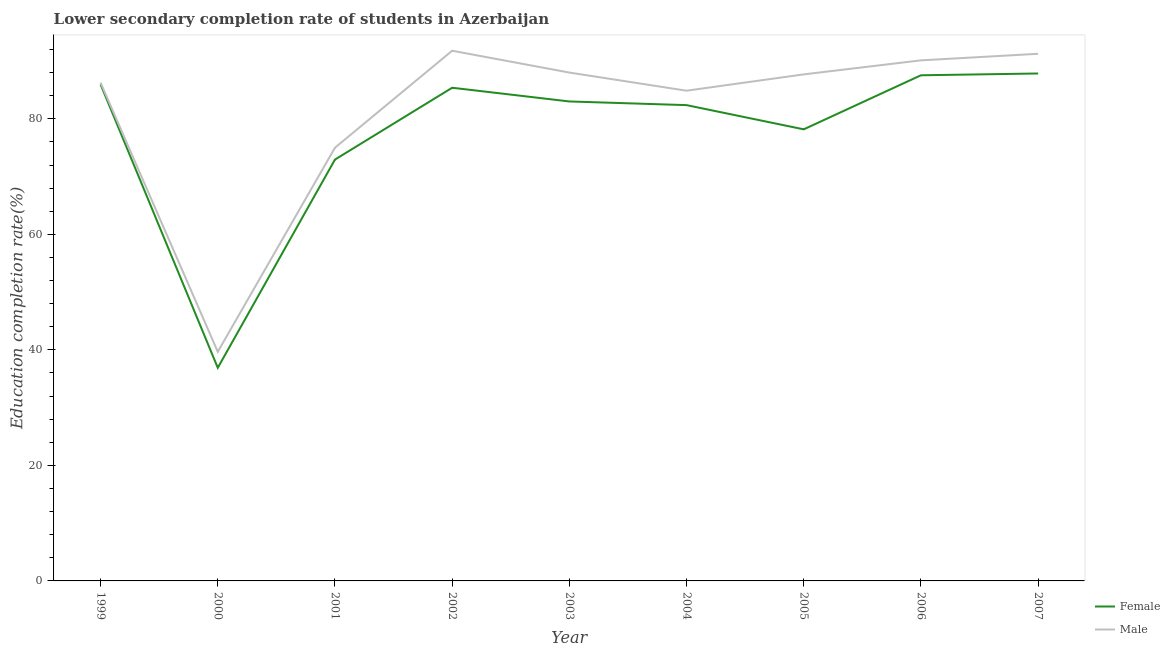Is the number of lines equal to the number of legend labels?
Give a very brief answer. Yes. What is the education completion rate of male students in 2001?
Your response must be concise. 75. Across all years, what is the maximum education completion rate of female students?
Your answer should be compact. 87.85. Across all years, what is the minimum education completion rate of male students?
Offer a very short reply. 39.67. In which year was the education completion rate of male students maximum?
Your answer should be very brief. 2002. In which year was the education completion rate of male students minimum?
Your response must be concise. 2000. What is the total education completion rate of female students in the graph?
Give a very brief answer. 700.11. What is the difference between the education completion rate of female students in 1999 and that in 2003?
Offer a terse response. 2.94. What is the difference between the education completion rate of male students in 2005 and the education completion rate of female students in 2003?
Provide a short and direct response. 4.69. What is the average education completion rate of female students per year?
Keep it short and to the point. 77.79. In the year 2002, what is the difference between the education completion rate of female students and education completion rate of male students?
Ensure brevity in your answer.  -6.41. In how many years, is the education completion rate of male students greater than 76 %?
Ensure brevity in your answer.  7. What is the ratio of the education completion rate of female students in 2001 to that in 2006?
Give a very brief answer. 0.83. What is the difference between the highest and the second highest education completion rate of female students?
Your answer should be very brief. 0.31. What is the difference between the highest and the lowest education completion rate of male students?
Your response must be concise. 52.12. Is the sum of the education completion rate of male students in 2000 and 2005 greater than the maximum education completion rate of female students across all years?
Provide a succinct answer. Yes. Does the graph contain any zero values?
Provide a succinct answer. No. Does the graph contain grids?
Give a very brief answer. No. How are the legend labels stacked?
Offer a very short reply. Vertical. What is the title of the graph?
Make the answer very short. Lower secondary completion rate of students in Azerbaijan. Does "Primary" appear as one of the legend labels in the graph?
Ensure brevity in your answer.  No. What is the label or title of the Y-axis?
Your response must be concise. Education completion rate(%). What is the Education completion rate(%) in Female in 1999?
Your answer should be very brief. 85.95. What is the Education completion rate(%) of Male in 1999?
Give a very brief answer. 86.26. What is the Education completion rate(%) in Female in 2000?
Make the answer very short. 36.9. What is the Education completion rate(%) in Male in 2000?
Provide a short and direct response. 39.67. What is the Education completion rate(%) of Female in 2001?
Make the answer very short. 72.95. What is the Education completion rate(%) in Female in 2002?
Provide a succinct answer. 85.38. What is the Education completion rate(%) of Male in 2002?
Your response must be concise. 91.79. What is the Education completion rate(%) in Female in 2003?
Provide a succinct answer. 83.01. What is the Education completion rate(%) of Male in 2003?
Ensure brevity in your answer.  88.01. What is the Education completion rate(%) in Female in 2004?
Your response must be concise. 82.37. What is the Education completion rate(%) in Male in 2004?
Make the answer very short. 84.87. What is the Education completion rate(%) of Female in 2005?
Your response must be concise. 78.18. What is the Education completion rate(%) in Male in 2005?
Ensure brevity in your answer.  87.69. What is the Education completion rate(%) in Female in 2006?
Provide a succinct answer. 87.54. What is the Education completion rate(%) in Male in 2006?
Offer a very short reply. 90.12. What is the Education completion rate(%) in Female in 2007?
Offer a very short reply. 87.85. What is the Education completion rate(%) in Male in 2007?
Your response must be concise. 91.26. Across all years, what is the maximum Education completion rate(%) of Female?
Keep it short and to the point. 87.85. Across all years, what is the maximum Education completion rate(%) of Male?
Ensure brevity in your answer.  91.79. Across all years, what is the minimum Education completion rate(%) of Female?
Keep it short and to the point. 36.9. Across all years, what is the minimum Education completion rate(%) in Male?
Your response must be concise. 39.67. What is the total Education completion rate(%) of Female in the graph?
Your answer should be compact. 700.11. What is the total Education completion rate(%) of Male in the graph?
Your answer should be very brief. 734.67. What is the difference between the Education completion rate(%) in Female in 1999 and that in 2000?
Make the answer very short. 49.05. What is the difference between the Education completion rate(%) in Male in 1999 and that in 2000?
Your answer should be compact. 46.6. What is the difference between the Education completion rate(%) in Female in 1999 and that in 2001?
Give a very brief answer. 13. What is the difference between the Education completion rate(%) of Male in 1999 and that in 2001?
Provide a succinct answer. 11.26. What is the difference between the Education completion rate(%) in Female in 1999 and that in 2002?
Keep it short and to the point. 0.57. What is the difference between the Education completion rate(%) in Male in 1999 and that in 2002?
Offer a very short reply. -5.52. What is the difference between the Education completion rate(%) in Female in 1999 and that in 2003?
Make the answer very short. 2.94. What is the difference between the Education completion rate(%) of Male in 1999 and that in 2003?
Give a very brief answer. -1.74. What is the difference between the Education completion rate(%) of Female in 1999 and that in 2004?
Your response must be concise. 3.58. What is the difference between the Education completion rate(%) of Male in 1999 and that in 2004?
Provide a succinct answer. 1.4. What is the difference between the Education completion rate(%) in Female in 1999 and that in 2005?
Make the answer very short. 7.77. What is the difference between the Education completion rate(%) of Male in 1999 and that in 2005?
Make the answer very short. -1.43. What is the difference between the Education completion rate(%) of Female in 1999 and that in 2006?
Your answer should be compact. -1.59. What is the difference between the Education completion rate(%) of Male in 1999 and that in 2006?
Give a very brief answer. -3.86. What is the difference between the Education completion rate(%) of Female in 1999 and that in 2007?
Ensure brevity in your answer.  -1.9. What is the difference between the Education completion rate(%) of Male in 1999 and that in 2007?
Offer a very short reply. -5. What is the difference between the Education completion rate(%) of Female in 2000 and that in 2001?
Provide a succinct answer. -36.05. What is the difference between the Education completion rate(%) in Male in 2000 and that in 2001?
Make the answer very short. -35.33. What is the difference between the Education completion rate(%) in Female in 2000 and that in 2002?
Your answer should be compact. -48.48. What is the difference between the Education completion rate(%) in Male in 2000 and that in 2002?
Make the answer very short. -52.12. What is the difference between the Education completion rate(%) of Female in 2000 and that in 2003?
Offer a terse response. -46.11. What is the difference between the Education completion rate(%) of Male in 2000 and that in 2003?
Provide a succinct answer. -48.34. What is the difference between the Education completion rate(%) in Female in 2000 and that in 2004?
Your answer should be compact. -45.47. What is the difference between the Education completion rate(%) in Male in 2000 and that in 2004?
Keep it short and to the point. -45.2. What is the difference between the Education completion rate(%) of Female in 2000 and that in 2005?
Offer a terse response. -41.28. What is the difference between the Education completion rate(%) of Male in 2000 and that in 2005?
Provide a short and direct response. -48.03. What is the difference between the Education completion rate(%) of Female in 2000 and that in 2006?
Ensure brevity in your answer.  -50.64. What is the difference between the Education completion rate(%) of Male in 2000 and that in 2006?
Offer a very short reply. -50.46. What is the difference between the Education completion rate(%) in Female in 2000 and that in 2007?
Offer a terse response. -50.95. What is the difference between the Education completion rate(%) of Male in 2000 and that in 2007?
Your answer should be compact. -51.59. What is the difference between the Education completion rate(%) in Female in 2001 and that in 2002?
Give a very brief answer. -12.43. What is the difference between the Education completion rate(%) in Male in 2001 and that in 2002?
Make the answer very short. -16.79. What is the difference between the Education completion rate(%) of Female in 2001 and that in 2003?
Make the answer very short. -10.06. What is the difference between the Education completion rate(%) of Male in 2001 and that in 2003?
Your answer should be very brief. -13.01. What is the difference between the Education completion rate(%) in Female in 2001 and that in 2004?
Your answer should be compact. -9.42. What is the difference between the Education completion rate(%) of Male in 2001 and that in 2004?
Keep it short and to the point. -9.87. What is the difference between the Education completion rate(%) in Female in 2001 and that in 2005?
Keep it short and to the point. -5.23. What is the difference between the Education completion rate(%) of Male in 2001 and that in 2005?
Provide a short and direct response. -12.69. What is the difference between the Education completion rate(%) in Female in 2001 and that in 2006?
Keep it short and to the point. -14.59. What is the difference between the Education completion rate(%) in Male in 2001 and that in 2006?
Offer a terse response. -15.12. What is the difference between the Education completion rate(%) in Female in 2001 and that in 2007?
Your answer should be compact. -14.9. What is the difference between the Education completion rate(%) in Male in 2001 and that in 2007?
Your answer should be compact. -16.26. What is the difference between the Education completion rate(%) in Female in 2002 and that in 2003?
Give a very brief answer. 2.38. What is the difference between the Education completion rate(%) in Male in 2002 and that in 2003?
Offer a terse response. 3.78. What is the difference between the Education completion rate(%) of Female in 2002 and that in 2004?
Provide a short and direct response. 3.01. What is the difference between the Education completion rate(%) in Male in 2002 and that in 2004?
Ensure brevity in your answer.  6.92. What is the difference between the Education completion rate(%) of Female in 2002 and that in 2005?
Make the answer very short. 7.2. What is the difference between the Education completion rate(%) of Male in 2002 and that in 2005?
Your answer should be compact. 4.09. What is the difference between the Education completion rate(%) in Female in 2002 and that in 2006?
Ensure brevity in your answer.  -2.16. What is the difference between the Education completion rate(%) in Male in 2002 and that in 2006?
Provide a succinct answer. 1.67. What is the difference between the Education completion rate(%) in Female in 2002 and that in 2007?
Offer a very short reply. -2.47. What is the difference between the Education completion rate(%) in Male in 2002 and that in 2007?
Give a very brief answer. 0.53. What is the difference between the Education completion rate(%) in Female in 2003 and that in 2004?
Ensure brevity in your answer.  0.63. What is the difference between the Education completion rate(%) in Male in 2003 and that in 2004?
Give a very brief answer. 3.14. What is the difference between the Education completion rate(%) in Female in 2003 and that in 2005?
Your answer should be compact. 4.83. What is the difference between the Education completion rate(%) in Male in 2003 and that in 2005?
Provide a succinct answer. 0.31. What is the difference between the Education completion rate(%) in Female in 2003 and that in 2006?
Give a very brief answer. -4.53. What is the difference between the Education completion rate(%) in Male in 2003 and that in 2006?
Your response must be concise. -2.11. What is the difference between the Education completion rate(%) in Female in 2003 and that in 2007?
Keep it short and to the point. -4.84. What is the difference between the Education completion rate(%) of Male in 2003 and that in 2007?
Provide a short and direct response. -3.25. What is the difference between the Education completion rate(%) in Female in 2004 and that in 2005?
Provide a short and direct response. 4.19. What is the difference between the Education completion rate(%) in Male in 2004 and that in 2005?
Ensure brevity in your answer.  -2.83. What is the difference between the Education completion rate(%) of Female in 2004 and that in 2006?
Your response must be concise. -5.17. What is the difference between the Education completion rate(%) in Male in 2004 and that in 2006?
Your answer should be compact. -5.25. What is the difference between the Education completion rate(%) in Female in 2004 and that in 2007?
Your answer should be compact. -5.48. What is the difference between the Education completion rate(%) in Male in 2004 and that in 2007?
Your answer should be very brief. -6.39. What is the difference between the Education completion rate(%) of Female in 2005 and that in 2006?
Keep it short and to the point. -9.36. What is the difference between the Education completion rate(%) of Male in 2005 and that in 2006?
Offer a terse response. -2.43. What is the difference between the Education completion rate(%) in Female in 2005 and that in 2007?
Your response must be concise. -9.67. What is the difference between the Education completion rate(%) of Male in 2005 and that in 2007?
Provide a succinct answer. -3.57. What is the difference between the Education completion rate(%) of Female in 2006 and that in 2007?
Your answer should be compact. -0.31. What is the difference between the Education completion rate(%) of Male in 2006 and that in 2007?
Give a very brief answer. -1.14. What is the difference between the Education completion rate(%) of Female in 1999 and the Education completion rate(%) of Male in 2000?
Your response must be concise. 46.28. What is the difference between the Education completion rate(%) of Female in 1999 and the Education completion rate(%) of Male in 2001?
Make the answer very short. 10.95. What is the difference between the Education completion rate(%) of Female in 1999 and the Education completion rate(%) of Male in 2002?
Offer a terse response. -5.84. What is the difference between the Education completion rate(%) in Female in 1999 and the Education completion rate(%) in Male in 2003?
Your answer should be compact. -2.06. What is the difference between the Education completion rate(%) in Female in 1999 and the Education completion rate(%) in Male in 2004?
Offer a very short reply. 1.08. What is the difference between the Education completion rate(%) of Female in 1999 and the Education completion rate(%) of Male in 2005?
Make the answer very short. -1.75. What is the difference between the Education completion rate(%) of Female in 1999 and the Education completion rate(%) of Male in 2006?
Make the answer very short. -4.17. What is the difference between the Education completion rate(%) of Female in 1999 and the Education completion rate(%) of Male in 2007?
Keep it short and to the point. -5.31. What is the difference between the Education completion rate(%) of Female in 2000 and the Education completion rate(%) of Male in 2001?
Offer a very short reply. -38.1. What is the difference between the Education completion rate(%) in Female in 2000 and the Education completion rate(%) in Male in 2002?
Make the answer very short. -54.89. What is the difference between the Education completion rate(%) in Female in 2000 and the Education completion rate(%) in Male in 2003?
Your response must be concise. -51.11. What is the difference between the Education completion rate(%) of Female in 2000 and the Education completion rate(%) of Male in 2004?
Offer a terse response. -47.97. What is the difference between the Education completion rate(%) in Female in 2000 and the Education completion rate(%) in Male in 2005?
Your answer should be very brief. -50.8. What is the difference between the Education completion rate(%) of Female in 2000 and the Education completion rate(%) of Male in 2006?
Keep it short and to the point. -53.22. What is the difference between the Education completion rate(%) of Female in 2000 and the Education completion rate(%) of Male in 2007?
Offer a terse response. -54.36. What is the difference between the Education completion rate(%) of Female in 2001 and the Education completion rate(%) of Male in 2002?
Ensure brevity in your answer.  -18.84. What is the difference between the Education completion rate(%) in Female in 2001 and the Education completion rate(%) in Male in 2003?
Your response must be concise. -15.06. What is the difference between the Education completion rate(%) of Female in 2001 and the Education completion rate(%) of Male in 2004?
Offer a terse response. -11.92. What is the difference between the Education completion rate(%) in Female in 2001 and the Education completion rate(%) in Male in 2005?
Give a very brief answer. -14.75. What is the difference between the Education completion rate(%) in Female in 2001 and the Education completion rate(%) in Male in 2006?
Keep it short and to the point. -17.17. What is the difference between the Education completion rate(%) of Female in 2001 and the Education completion rate(%) of Male in 2007?
Your answer should be compact. -18.31. What is the difference between the Education completion rate(%) in Female in 2002 and the Education completion rate(%) in Male in 2003?
Your response must be concise. -2.63. What is the difference between the Education completion rate(%) in Female in 2002 and the Education completion rate(%) in Male in 2004?
Offer a terse response. 0.51. What is the difference between the Education completion rate(%) in Female in 2002 and the Education completion rate(%) in Male in 2005?
Your response must be concise. -2.31. What is the difference between the Education completion rate(%) in Female in 2002 and the Education completion rate(%) in Male in 2006?
Ensure brevity in your answer.  -4.74. What is the difference between the Education completion rate(%) in Female in 2002 and the Education completion rate(%) in Male in 2007?
Provide a short and direct response. -5.88. What is the difference between the Education completion rate(%) of Female in 2003 and the Education completion rate(%) of Male in 2004?
Provide a short and direct response. -1.86. What is the difference between the Education completion rate(%) of Female in 2003 and the Education completion rate(%) of Male in 2005?
Ensure brevity in your answer.  -4.69. What is the difference between the Education completion rate(%) of Female in 2003 and the Education completion rate(%) of Male in 2006?
Offer a very short reply. -7.12. What is the difference between the Education completion rate(%) in Female in 2003 and the Education completion rate(%) in Male in 2007?
Your response must be concise. -8.25. What is the difference between the Education completion rate(%) of Female in 2004 and the Education completion rate(%) of Male in 2005?
Provide a succinct answer. -5.32. What is the difference between the Education completion rate(%) of Female in 2004 and the Education completion rate(%) of Male in 2006?
Make the answer very short. -7.75. What is the difference between the Education completion rate(%) in Female in 2004 and the Education completion rate(%) in Male in 2007?
Provide a short and direct response. -8.89. What is the difference between the Education completion rate(%) in Female in 2005 and the Education completion rate(%) in Male in 2006?
Offer a very short reply. -11.94. What is the difference between the Education completion rate(%) in Female in 2005 and the Education completion rate(%) in Male in 2007?
Ensure brevity in your answer.  -13.08. What is the difference between the Education completion rate(%) in Female in 2006 and the Education completion rate(%) in Male in 2007?
Make the answer very short. -3.72. What is the average Education completion rate(%) in Female per year?
Ensure brevity in your answer.  77.79. What is the average Education completion rate(%) of Male per year?
Give a very brief answer. 81.63. In the year 1999, what is the difference between the Education completion rate(%) in Female and Education completion rate(%) in Male?
Provide a short and direct response. -0.32. In the year 2000, what is the difference between the Education completion rate(%) in Female and Education completion rate(%) in Male?
Provide a succinct answer. -2.77. In the year 2001, what is the difference between the Education completion rate(%) in Female and Education completion rate(%) in Male?
Your answer should be very brief. -2.05. In the year 2002, what is the difference between the Education completion rate(%) in Female and Education completion rate(%) in Male?
Your response must be concise. -6.41. In the year 2003, what is the difference between the Education completion rate(%) in Female and Education completion rate(%) in Male?
Your answer should be compact. -5. In the year 2004, what is the difference between the Education completion rate(%) of Female and Education completion rate(%) of Male?
Your response must be concise. -2.5. In the year 2005, what is the difference between the Education completion rate(%) of Female and Education completion rate(%) of Male?
Your answer should be compact. -9.51. In the year 2006, what is the difference between the Education completion rate(%) in Female and Education completion rate(%) in Male?
Make the answer very short. -2.58. In the year 2007, what is the difference between the Education completion rate(%) of Female and Education completion rate(%) of Male?
Ensure brevity in your answer.  -3.41. What is the ratio of the Education completion rate(%) of Female in 1999 to that in 2000?
Offer a very short reply. 2.33. What is the ratio of the Education completion rate(%) in Male in 1999 to that in 2000?
Give a very brief answer. 2.17. What is the ratio of the Education completion rate(%) of Female in 1999 to that in 2001?
Offer a terse response. 1.18. What is the ratio of the Education completion rate(%) in Male in 1999 to that in 2001?
Give a very brief answer. 1.15. What is the ratio of the Education completion rate(%) in Female in 1999 to that in 2002?
Make the answer very short. 1.01. What is the ratio of the Education completion rate(%) in Male in 1999 to that in 2002?
Your answer should be compact. 0.94. What is the ratio of the Education completion rate(%) in Female in 1999 to that in 2003?
Make the answer very short. 1.04. What is the ratio of the Education completion rate(%) of Male in 1999 to that in 2003?
Your answer should be compact. 0.98. What is the ratio of the Education completion rate(%) in Female in 1999 to that in 2004?
Offer a terse response. 1.04. What is the ratio of the Education completion rate(%) of Male in 1999 to that in 2004?
Give a very brief answer. 1.02. What is the ratio of the Education completion rate(%) in Female in 1999 to that in 2005?
Make the answer very short. 1.1. What is the ratio of the Education completion rate(%) in Male in 1999 to that in 2005?
Keep it short and to the point. 0.98. What is the ratio of the Education completion rate(%) in Female in 1999 to that in 2006?
Your response must be concise. 0.98. What is the ratio of the Education completion rate(%) in Male in 1999 to that in 2006?
Provide a succinct answer. 0.96. What is the ratio of the Education completion rate(%) of Female in 1999 to that in 2007?
Your answer should be very brief. 0.98. What is the ratio of the Education completion rate(%) in Male in 1999 to that in 2007?
Give a very brief answer. 0.95. What is the ratio of the Education completion rate(%) of Female in 2000 to that in 2001?
Make the answer very short. 0.51. What is the ratio of the Education completion rate(%) in Male in 2000 to that in 2001?
Your response must be concise. 0.53. What is the ratio of the Education completion rate(%) of Female in 2000 to that in 2002?
Your answer should be compact. 0.43. What is the ratio of the Education completion rate(%) of Male in 2000 to that in 2002?
Ensure brevity in your answer.  0.43. What is the ratio of the Education completion rate(%) in Female in 2000 to that in 2003?
Offer a very short reply. 0.44. What is the ratio of the Education completion rate(%) of Male in 2000 to that in 2003?
Provide a succinct answer. 0.45. What is the ratio of the Education completion rate(%) in Female in 2000 to that in 2004?
Your answer should be very brief. 0.45. What is the ratio of the Education completion rate(%) of Male in 2000 to that in 2004?
Provide a succinct answer. 0.47. What is the ratio of the Education completion rate(%) of Female in 2000 to that in 2005?
Make the answer very short. 0.47. What is the ratio of the Education completion rate(%) in Male in 2000 to that in 2005?
Ensure brevity in your answer.  0.45. What is the ratio of the Education completion rate(%) in Female in 2000 to that in 2006?
Make the answer very short. 0.42. What is the ratio of the Education completion rate(%) in Male in 2000 to that in 2006?
Give a very brief answer. 0.44. What is the ratio of the Education completion rate(%) in Female in 2000 to that in 2007?
Offer a very short reply. 0.42. What is the ratio of the Education completion rate(%) in Male in 2000 to that in 2007?
Ensure brevity in your answer.  0.43. What is the ratio of the Education completion rate(%) in Female in 2001 to that in 2002?
Make the answer very short. 0.85. What is the ratio of the Education completion rate(%) of Male in 2001 to that in 2002?
Provide a succinct answer. 0.82. What is the ratio of the Education completion rate(%) in Female in 2001 to that in 2003?
Make the answer very short. 0.88. What is the ratio of the Education completion rate(%) in Male in 2001 to that in 2003?
Keep it short and to the point. 0.85. What is the ratio of the Education completion rate(%) of Female in 2001 to that in 2004?
Offer a terse response. 0.89. What is the ratio of the Education completion rate(%) in Male in 2001 to that in 2004?
Keep it short and to the point. 0.88. What is the ratio of the Education completion rate(%) of Female in 2001 to that in 2005?
Provide a succinct answer. 0.93. What is the ratio of the Education completion rate(%) in Male in 2001 to that in 2005?
Your answer should be very brief. 0.86. What is the ratio of the Education completion rate(%) of Female in 2001 to that in 2006?
Ensure brevity in your answer.  0.83. What is the ratio of the Education completion rate(%) in Male in 2001 to that in 2006?
Make the answer very short. 0.83. What is the ratio of the Education completion rate(%) in Female in 2001 to that in 2007?
Your response must be concise. 0.83. What is the ratio of the Education completion rate(%) of Male in 2001 to that in 2007?
Give a very brief answer. 0.82. What is the ratio of the Education completion rate(%) of Female in 2002 to that in 2003?
Provide a short and direct response. 1.03. What is the ratio of the Education completion rate(%) of Male in 2002 to that in 2003?
Ensure brevity in your answer.  1.04. What is the ratio of the Education completion rate(%) of Female in 2002 to that in 2004?
Ensure brevity in your answer.  1.04. What is the ratio of the Education completion rate(%) of Male in 2002 to that in 2004?
Offer a terse response. 1.08. What is the ratio of the Education completion rate(%) of Female in 2002 to that in 2005?
Your answer should be very brief. 1.09. What is the ratio of the Education completion rate(%) in Male in 2002 to that in 2005?
Ensure brevity in your answer.  1.05. What is the ratio of the Education completion rate(%) in Female in 2002 to that in 2006?
Provide a short and direct response. 0.98. What is the ratio of the Education completion rate(%) in Male in 2002 to that in 2006?
Offer a very short reply. 1.02. What is the ratio of the Education completion rate(%) in Female in 2002 to that in 2007?
Offer a terse response. 0.97. What is the ratio of the Education completion rate(%) in Male in 2002 to that in 2007?
Keep it short and to the point. 1.01. What is the ratio of the Education completion rate(%) in Female in 2003 to that in 2004?
Your answer should be very brief. 1.01. What is the ratio of the Education completion rate(%) in Female in 2003 to that in 2005?
Your answer should be very brief. 1.06. What is the ratio of the Education completion rate(%) in Female in 2003 to that in 2006?
Your answer should be very brief. 0.95. What is the ratio of the Education completion rate(%) of Male in 2003 to that in 2006?
Ensure brevity in your answer.  0.98. What is the ratio of the Education completion rate(%) in Female in 2003 to that in 2007?
Make the answer very short. 0.94. What is the ratio of the Education completion rate(%) in Male in 2003 to that in 2007?
Provide a succinct answer. 0.96. What is the ratio of the Education completion rate(%) of Female in 2004 to that in 2005?
Provide a short and direct response. 1.05. What is the ratio of the Education completion rate(%) in Male in 2004 to that in 2005?
Provide a succinct answer. 0.97. What is the ratio of the Education completion rate(%) of Female in 2004 to that in 2006?
Offer a very short reply. 0.94. What is the ratio of the Education completion rate(%) in Male in 2004 to that in 2006?
Your answer should be very brief. 0.94. What is the ratio of the Education completion rate(%) of Female in 2004 to that in 2007?
Provide a short and direct response. 0.94. What is the ratio of the Education completion rate(%) in Female in 2005 to that in 2006?
Give a very brief answer. 0.89. What is the ratio of the Education completion rate(%) in Male in 2005 to that in 2006?
Provide a succinct answer. 0.97. What is the ratio of the Education completion rate(%) of Female in 2005 to that in 2007?
Your response must be concise. 0.89. What is the ratio of the Education completion rate(%) of Male in 2005 to that in 2007?
Ensure brevity in your answer.  0.96. What is the ratio of the Education completion rate(%) in Female in 2006 to that in 2007?
Give a very brief answer. 1. What is the ratio of the Education completion rate(%) in Male in 2006 to that in 2007?
Make the answer very short. 0.99. What is the difference between the highest and the second highest Education completion rate(%) in Female?
Keep it short and to the point. 0.31. What is the difference between the highest and the second highest Education completion rate(%) in Male?
Make the answer very short. 0.53. What is the difference between the highest and the lowest Education completion rate(%) of Female?
Give a very brief answer. 50.95. What is the difference between the highest and the lowest Education completion rate(%) in Male?
Offer a very short reply. 52.12. 